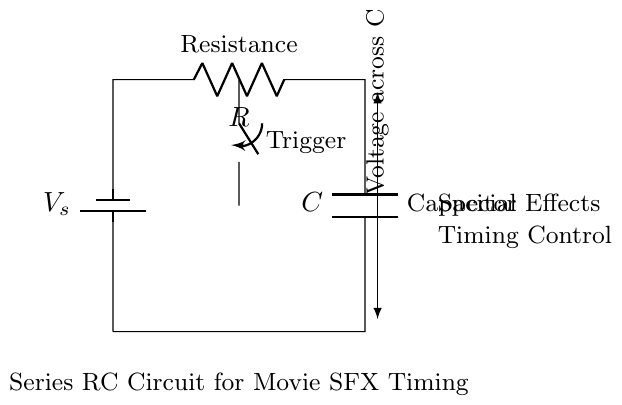What is the voltage source in this circuit? The voltage source is labeled as V_s in the circuit diagram, which indicates it provides the input voltage for the entire circuit.
Answer: V_s What components are connected in series in this circuit? The components connected in series are the resistor, R, and the capacitor, C. In a series circuit, the current flows through each component one after the other, hence both are connected in the same path.
Answer: Resistor and Capacitor What is the purpose of the switch in this circuit? The switch is used as a trigger, which allows the user to control when the circuit is activated, starting the timing sequence for the special effects in film production.
Answer: Trigger What does the voltage across C represent at steady state? At steady state, after a long time, the capacitor will be fully charged and the voltage across C will equal the source voltage, V_s, because no current flows through the capacitor in that state.
Answer: V_s How does the resistance value affect the timing of the circuit? The resistance, R, is inversely related to the time constant of the circuit, which determines how quickly the capacitor charges or discharges. Increasing R will increase the time constant, meaning the effect will take longer to occur.
Answer: Increases time What is the time constant for this RC circuit? The time constant (τ) is calculated using the formula τ = R * C, where R is the resistance and C is the capacitance. This value determines the time it takes for the capacitor to charge or discharge to approximately 63.2% of its maximum voltage.
Answer: R * C What type of effect is this circuit designed to control in film production? The circuit is designed to control special effects timing, allowing precise electrical timing for visual effects, such as lights or sound, to synchronize with film actions.
Answer: Special effects timing 